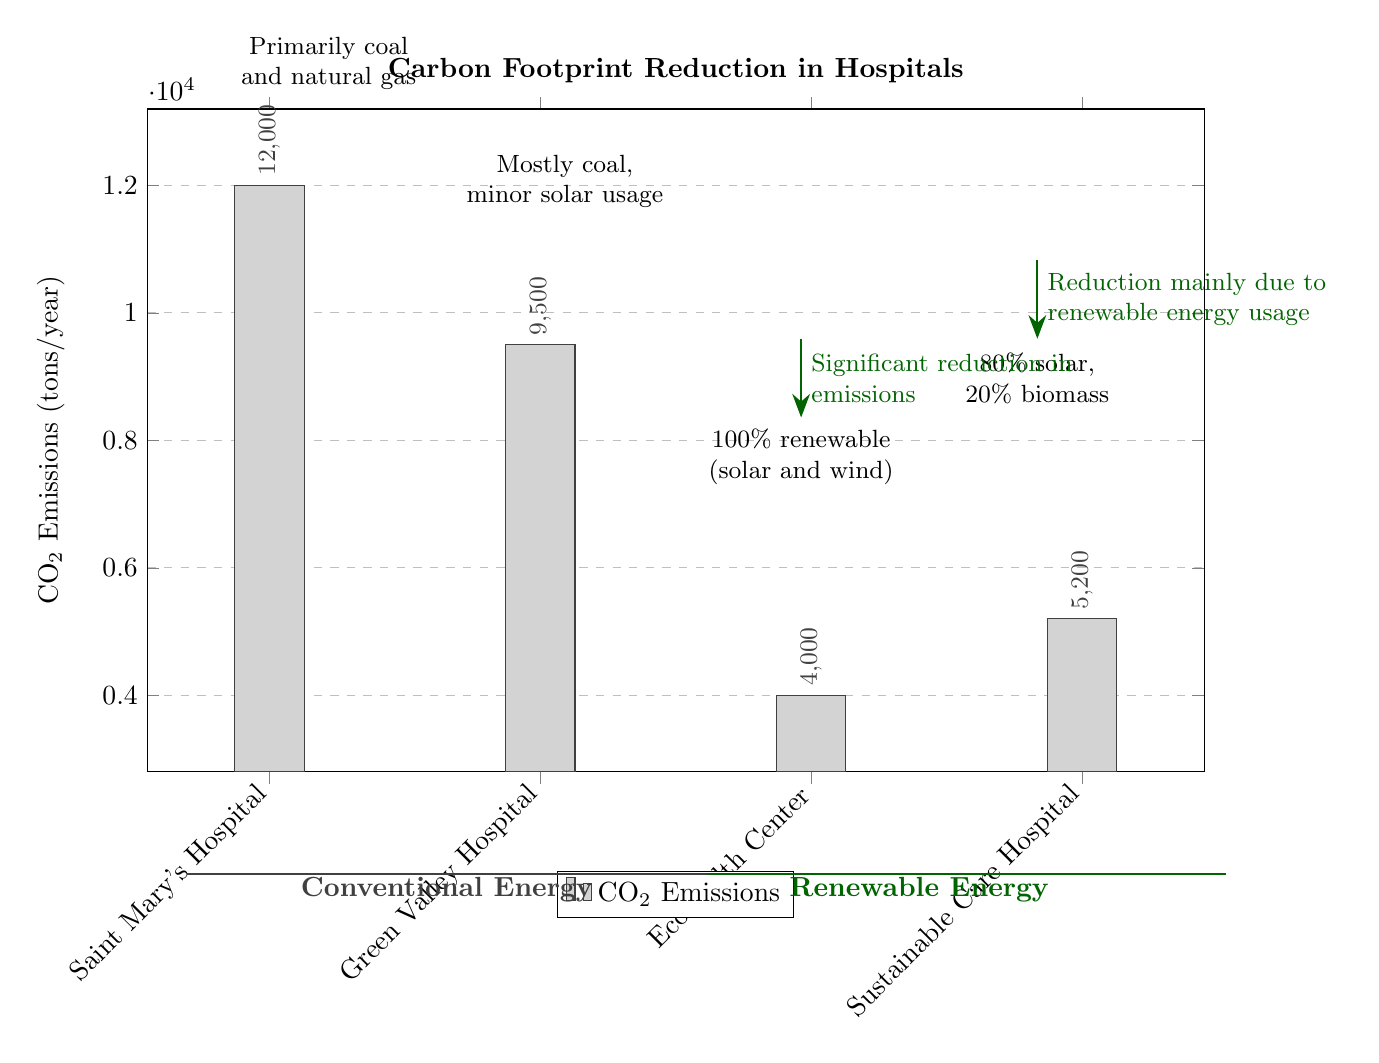What is the CO2 emission of EcoHealth Center? The CO2 emissions for EcoHealth Center is directly taken from the bar graph, which shows the value clearly labeled above the corresponding bar. The height of the bar for EcoHealth Center reflects the emissions, which is indicated to be 4000 tons/year.
Answer: 4000 tons/year Which hospital has the highest carbon footprint? To determine the highest carbon footprint, we look at the heights of the bars in the graph. Saint Mary's Hospital has the tallest bar, showing the highest emissions at 12000 tons/year.
Answer: Saint Mary's Hospital What type of energy does EcoHealth Center primarily use? The annotation next to the EcoHealth Center bar states "100% renewable (solar and wind)," indicating the type of energy used by that hospital.
Answer: 100% renewable (solar and wind) How many hospitals use renewable energy sources? The graph shows two hospitals with emissions in the renewable energy category: EcoHealth Center and Sustainable Care Hospital. This means there are two hospitals that utilize renewable energy.
Answer: 2 hospitals What is the CO2 emission difference between Saint Mary's Hospital and Sustainable Care Hospital? The CO2 emissions for Saint Mary's Hospital is 12000 tons/year, while Sustainable Care Hospital is 5200 tons/year. The difference can be calculated by subtracting the latter from the former: 12000 - 5200 = 6800 tons/year.
Answer: 6800 tons/year What kind of energy does Green Valley Hospital primarily use? The annotation next to the Green Valley Hospital states "Mostly coal, minor solar usage," which identifies the energy sources they rely on.
Answer: Mostly coal, minor solar usage What does the dark green color represent in this diagram? The color coding in the diagram distinguishes types of energy sources. The dark green color is used for bars representing hospitals that utilize renewable energy, as indicated in the legend at the bottom.
Answer: Renewable Energy Which hospital shows a significant reduction in emissions? The diagram includes an annotation next to the EcoHealth Center that states "Significant reduction in emissions," indicating that this hospital exhibits a notable decrease compared to others.
Answer: EcoHealth Center 